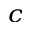Convert formula to latex. <formula><loc_0><loc_0><loc_500><loc_500>^ { c }</formula> 